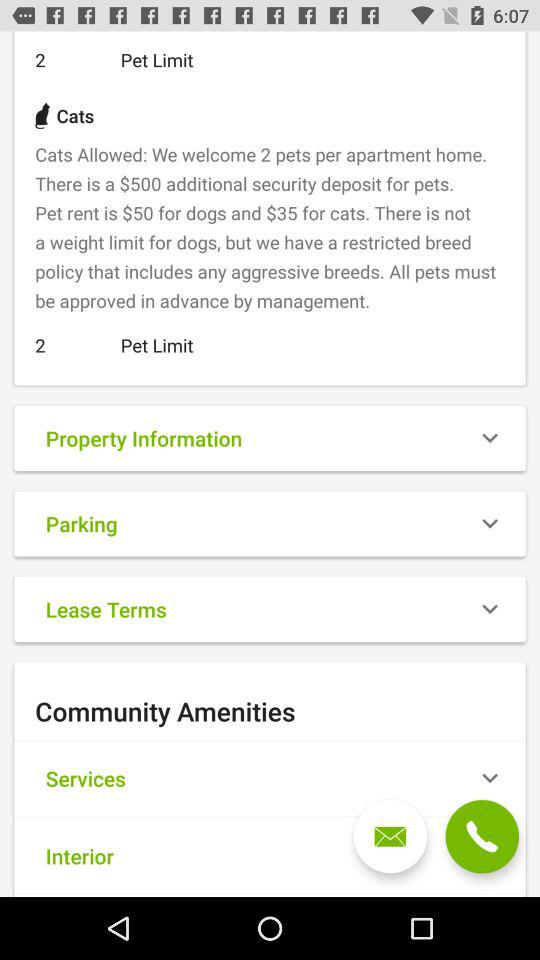How many pets are allowed per apartment? There are 2 pets allowed per apartment. 